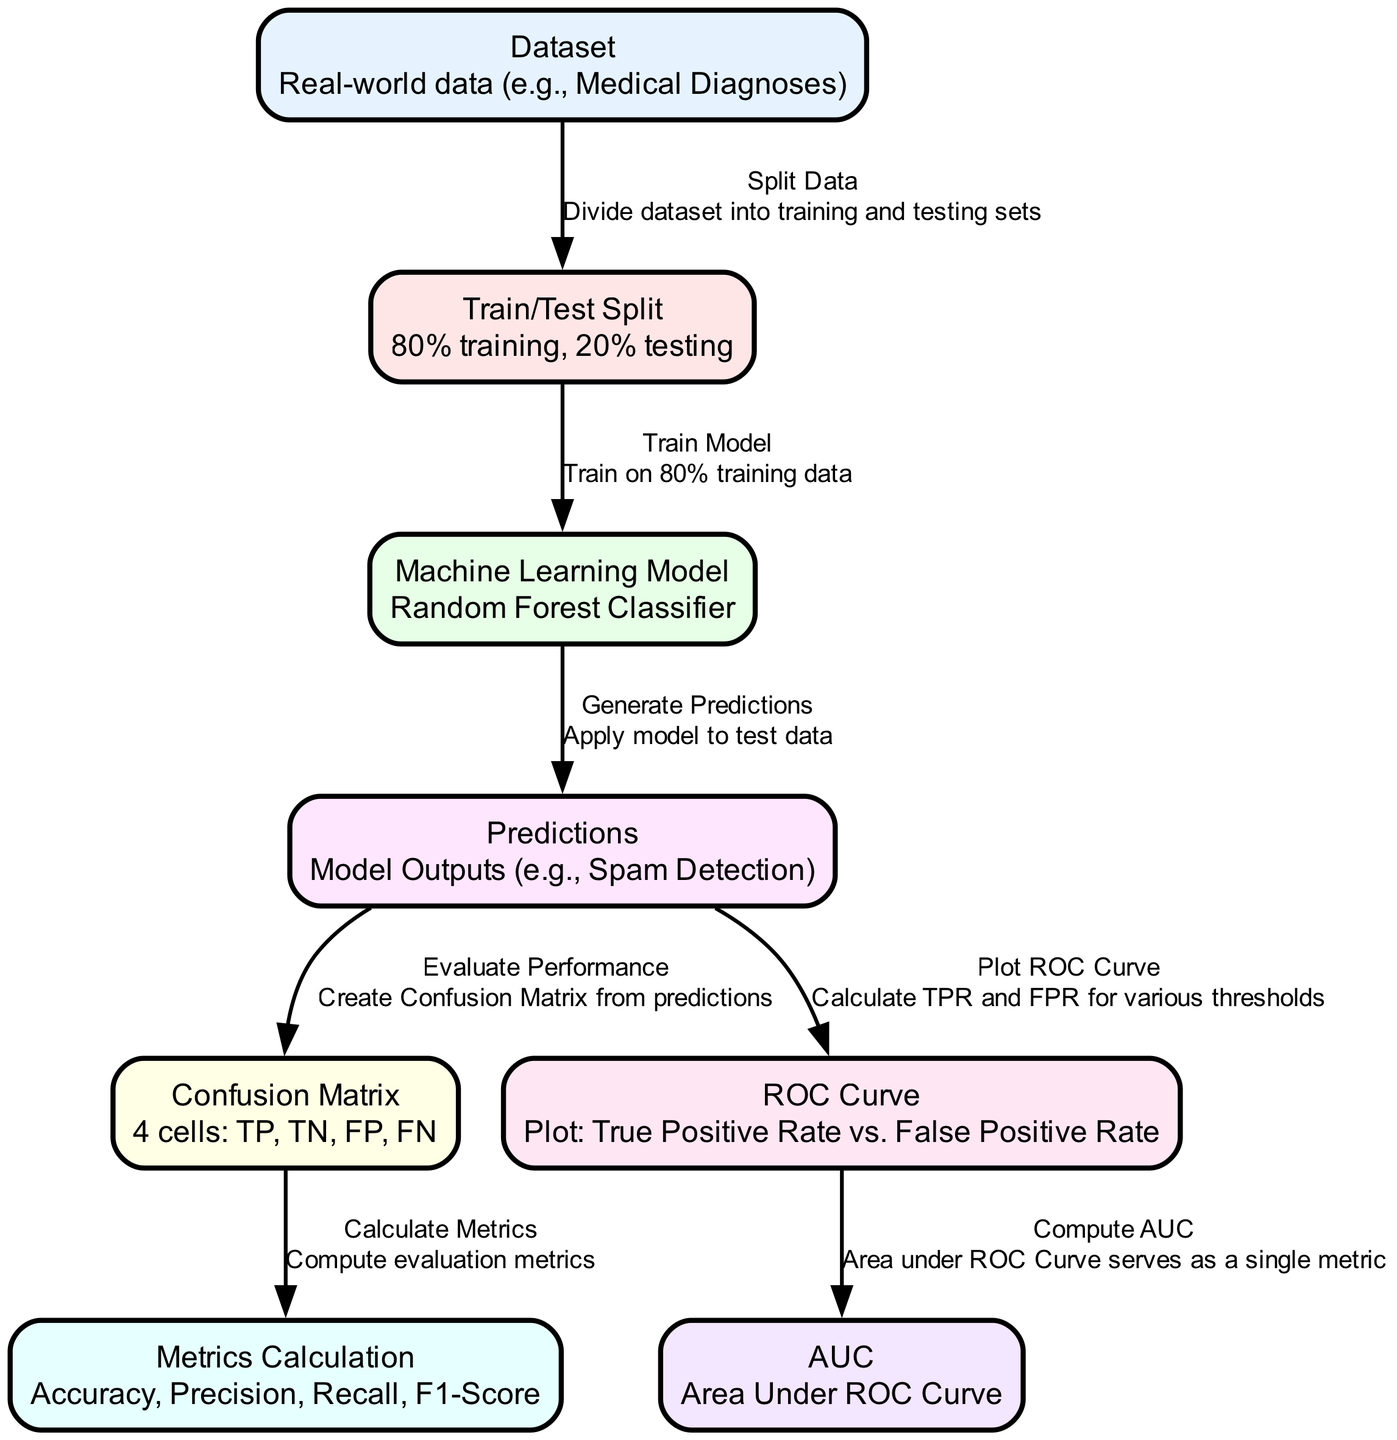What is the first step shown in the diagram? The first step involves starting with the "Dataset" node where real-world data (e.g., Medical Diagnoses) is introduced. This initiates the process of machine learning model evaluation.
Answer: Dataset How many nodes are represented in the diagram? By counting each of the distinct boxes labeled in the diagram, which include the nodes from "Dataset" to "AUC", a total of 8 nodes are present.
Answer: 8 What is the relationship between "Predictions" and "Confusion Matrix"? The relationship is one of evaluation; "Predictions" are used to "Evaluate Performance" which results in the creation of a "Confusion Matrix" that contains the True Positives, True Negatives, False Positives, and False Negatives.
Answer: Evaluate Performance What metric is used to quantify the performance of the ROC Curve? The performance of the ROC Curve is quantified using the "AUC" or Area Under the Curve, which summarizes the model's ability to distinguish between classes with a single value.
Answer: AUC What percentage of data is used for the training set according to the diagram? The diagram specifies that 80% of the data is allocated for training purposes, as mentioned in the "Train/Test Split" node.
Answer: 80% How does the "Machine Learning Model" relate to "Predictions"? The "Machine Learning Model" generates "Predictions" by applying the trained model to the test data, thus producing outputs such as spam detection results. This flow indicates that predictions are the result of the model's application.
Answer: Generate Predictions What metrics are calculated after the "Confusion Matrix"? After evaluating the "Confusion Matrix," the next step is calculating multiple performance metrics including Accuracy, Precision, Recall, and F1-Score in the "Metrics Calculation" node.
Answer: Accuracy, Precision, Recall, F1-Score What two rates are plotted on the ROC Curve? The ROC Curve plots the "True Positive Rate" against the "False Positive Rate," which are crucial for understanding the trade-offs between sensitivity and specificity in a model's predictions.
Answer: True Positive Rate, False Positive Rate 